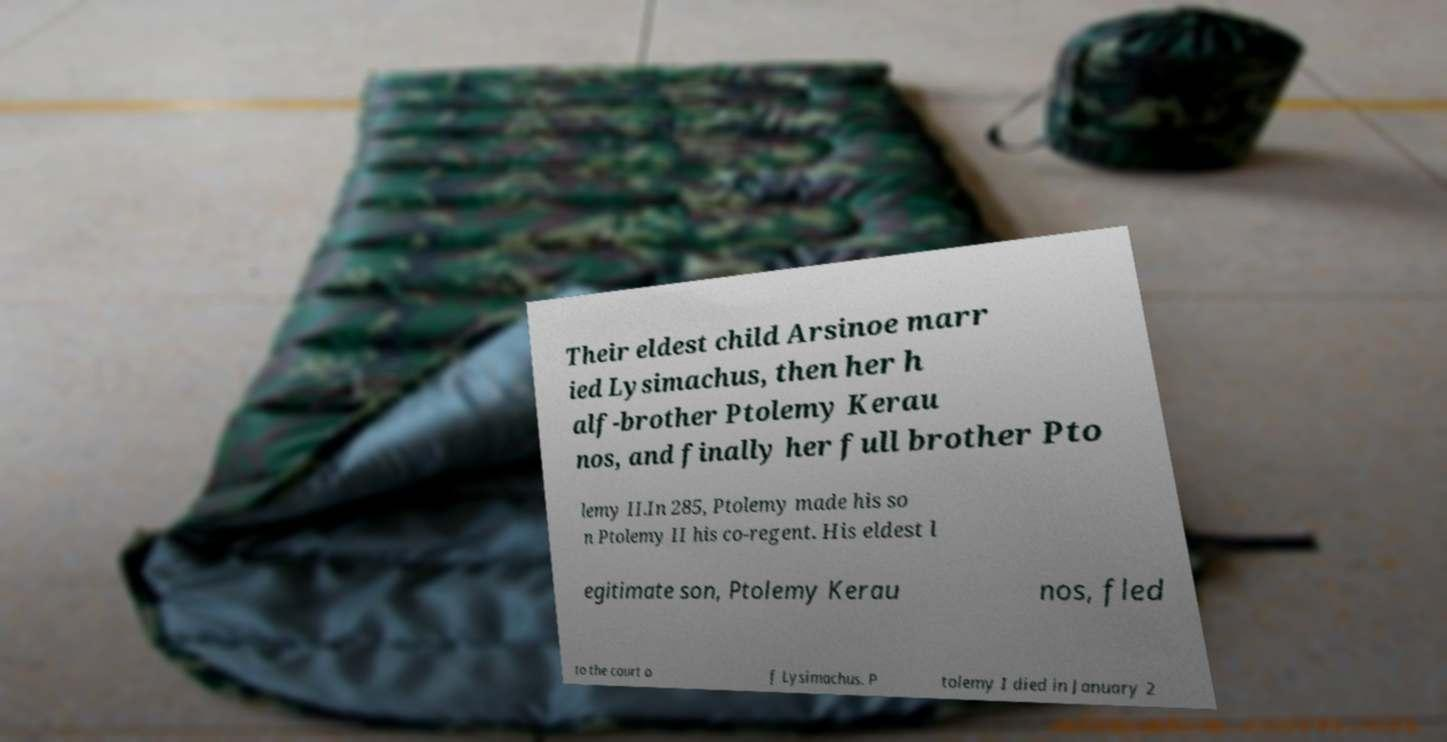Could you extract and type out the text from this image? Their eldest child Arsinoe marr ied Lysimachus, then her h alf-brother Ptolemy Kerau nos, and finally her full brother Pto lemy II.In 285, Ptolemy made his so n Ptolemy II his co-regent. His eldest l egitimate son, Ptolemy Kerau nos, fled to the court o f Lysimachus. P tolemy I died in January 2 